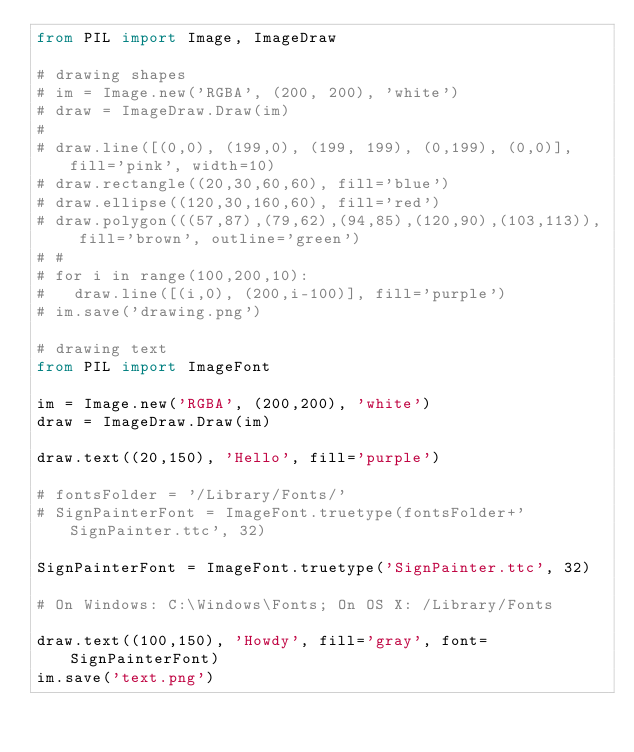<code> <loc_0><loc_0><loc_500><loc_500><_Python_>from PIL import Image, ImageDraw

# drawing shapes
# im = Image.new('RGBA', (200, 200), 'white')
# draw = ImageDraw.Draw(im)
#
# draw.line([(0,0), (199,0), (199, 199), (0,199), (0,0)], fill='pink', width=10)
# draw.rectangle((20,30,60,60), fill='blue')
# draw.ellipse((120,30,160,60), fill='red')
# draw.polygon(((57,87),(79,62),(94,85),(120,90),(103,113)), fill='brown', outline='green')
# #
# for i in range(100,200,10):
# 	draw.line([(i,0), (200,i-100)], fill='purple')
# im.save('drawing.png')

# drawing text
from PIL import ImageFont

im = Image.new('RGBA', (200,200), 'white')
draw = ImageDraw.Draw(im)

draw.text((20,150), 'Hello', fill='purple')

# fontsFolder = '/Library/Fonts/'
# SignPainterFont = ImageFont.truetype(fontsFolder+'SignPainter.ttc', 32)

SignPainterFont = ImageFont.truetype('SignPainter.ttc', 32)

# On Windows: C:\Windows\Fonts; On OS X: /Library/Fonts

draw.text((100,150), 'Howdy', fill='gray', font=SignPainterFont)
im.save('text.png')


</code> 